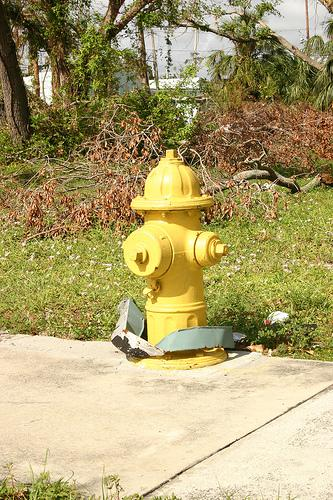Question: where is the dead branch?
Choices:
A. In leaves.
B. On the grass.
C. On field.
D. On water.
Answer with the letter. Answer: B Question: who would use this hydrant in their work?
Choices:
A. Neighbors.
B. Firemen.
C. Residents.
D. Police.
Answer with the letter. Answer: B Question: what are the brown things on the branch?
Choices:
A. Pine cones.
B. Dead leaves.
C. Cocoons.
D. Insects.
Answer with the letter. Answer: B Question: what is the hydrant on?
Choices:
A. Sidewalk.
B. Street.
C. Ground.
D. Grass.
Answer with the letter. Answer: A Question: what runs across the sidewalk?
Choices:
A. A pipe.
B. Chalk drawing.
C. Crack.
D. Grate.
Answer with the letter. Answer: C 